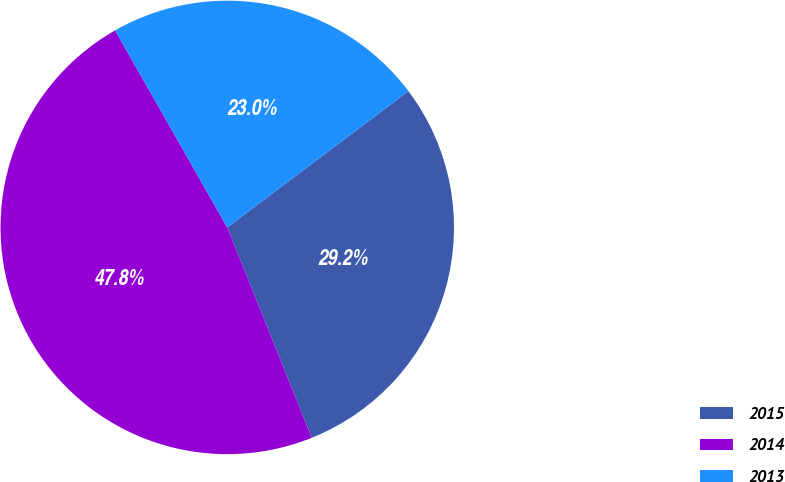Convert chart. <chart><loc_0><loc_0><loc_500><loc_500><pie_chart><fcel>2015<fcel>2014<fcel>2013<nl><fcel>29.19%<fcel>47.85%<fcel>22.97%<nl></chart> 